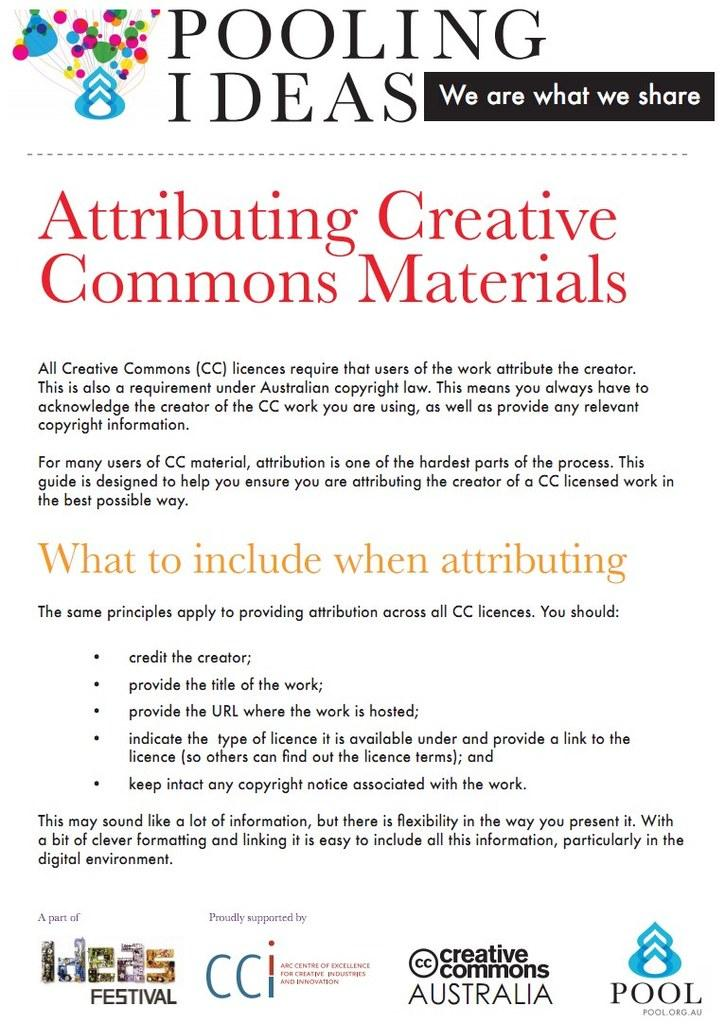What is present in the image that has text on it? There is a poster in the image that has text on it. What can be observed about the text on the poster? The text on the poster is in different colors. Is there a boy on a voyage with an oven in the image? There is no boy, voyage, or oven present in the image. The image only contains a poster with text in different colors. 